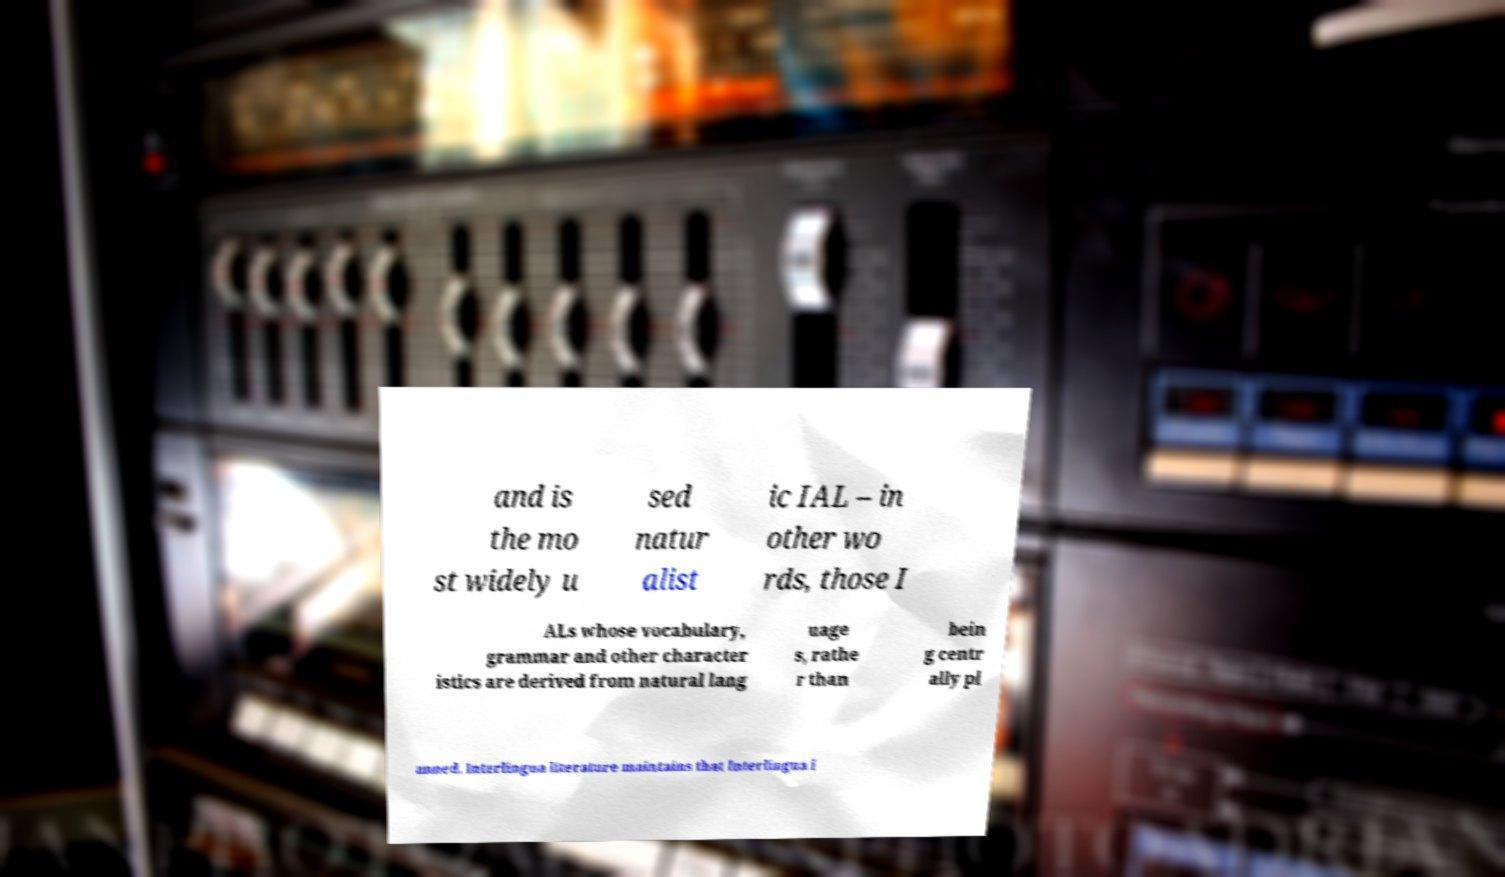What messages or text are displayed in this image? I need them in a readable, typed format. and is the mo st widely u sed natur alist ic IAL – in other wo rds, those I ALs whose vocabulary, grammar and other character istics are derived from natural lang uage s, rathe r than bein g centr ally pl anned. Interlingua literature maintains that Interlingua i 